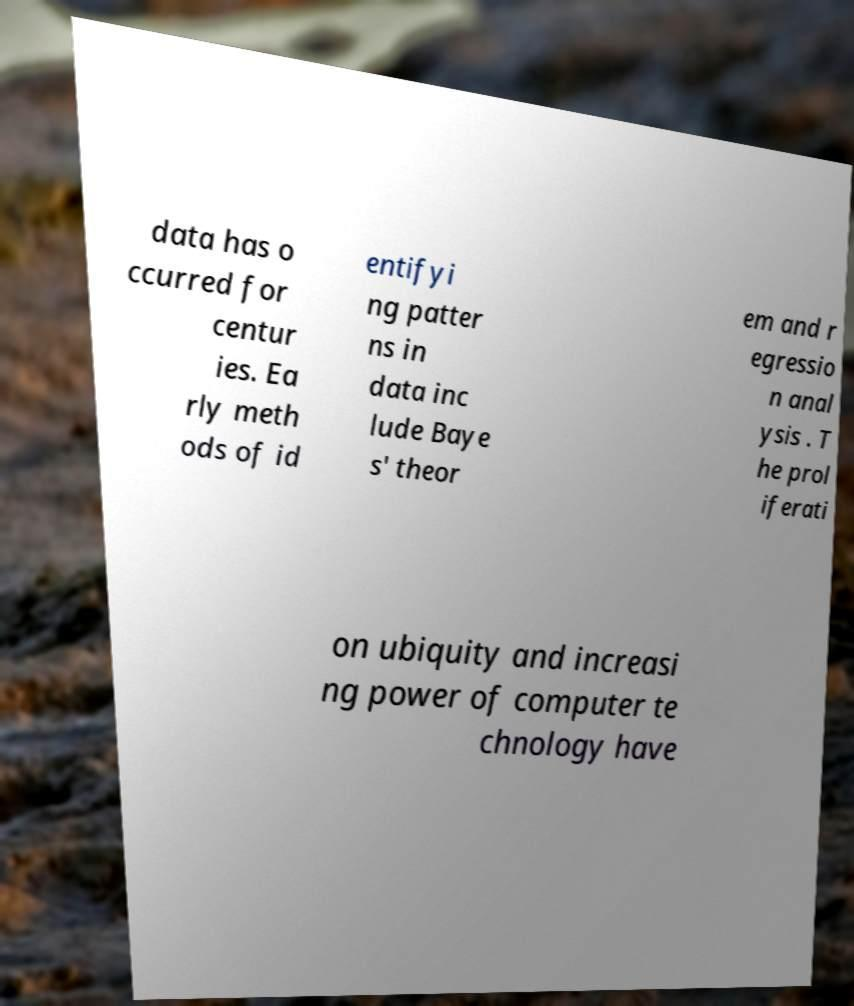What messages or text are displayed in this image? I need them in a readable, typed format. data has o ccurred for centur ies. Ea rly meth ods of id entifyi ng patter ns in data inc lude Baye s' theor em and r egressio n anal ysis . T he prol iferati on ubiquity and increasi ng power of computer te chnology have 